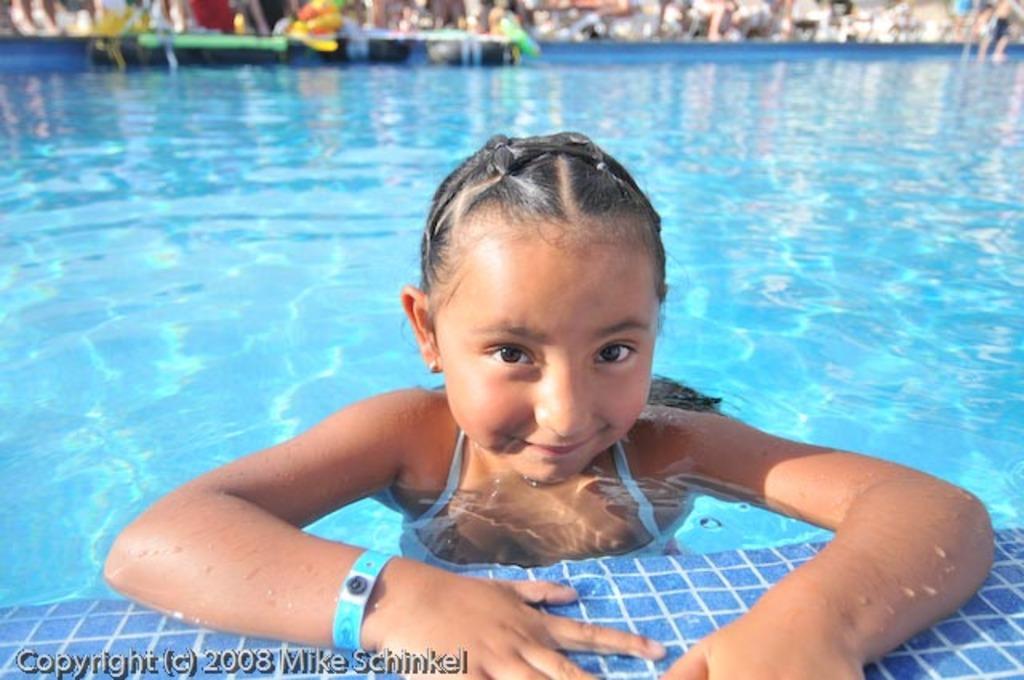Can you describe this image briefly? In this image there is a girl in swimming pool is smiling, and there is blur background and a watermark on the image. 